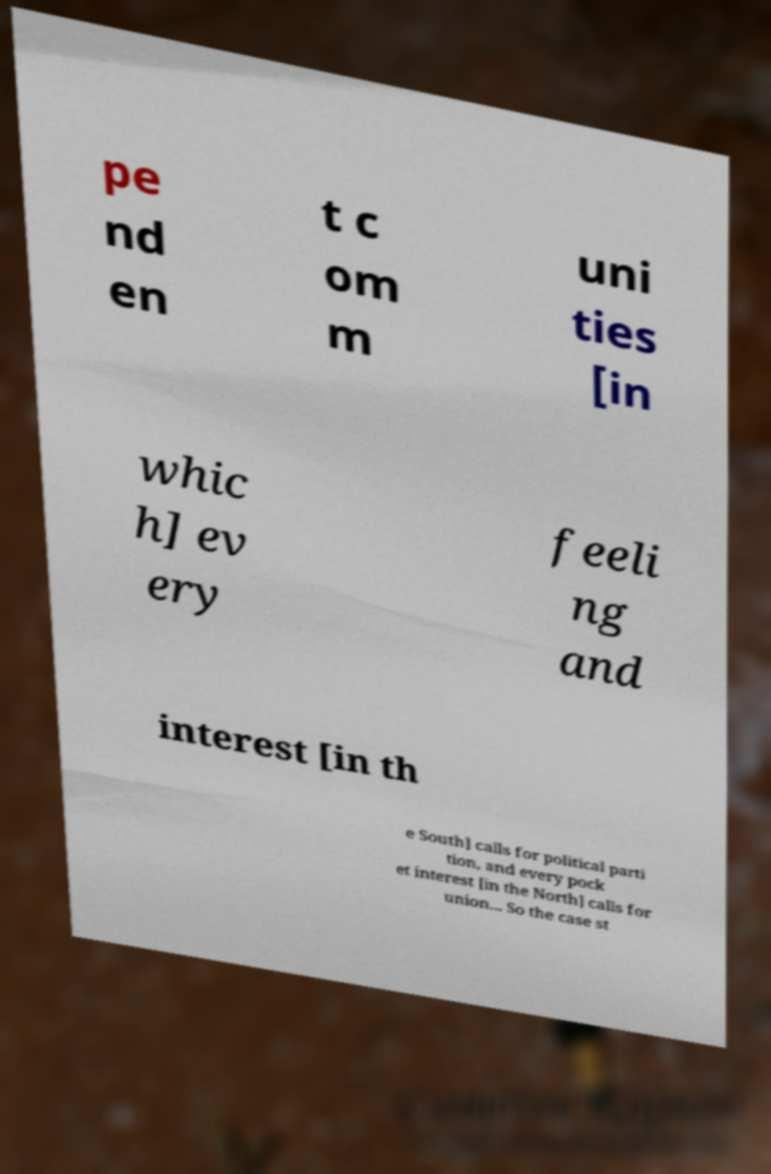Could you extract and type out the text from this image? pe nd en t c om m uni ties [in whic h] ev ery feeli ng and interest [in th e South] calls for political parti tion, and every pock et interest [in the North] calls for union... So the case st 